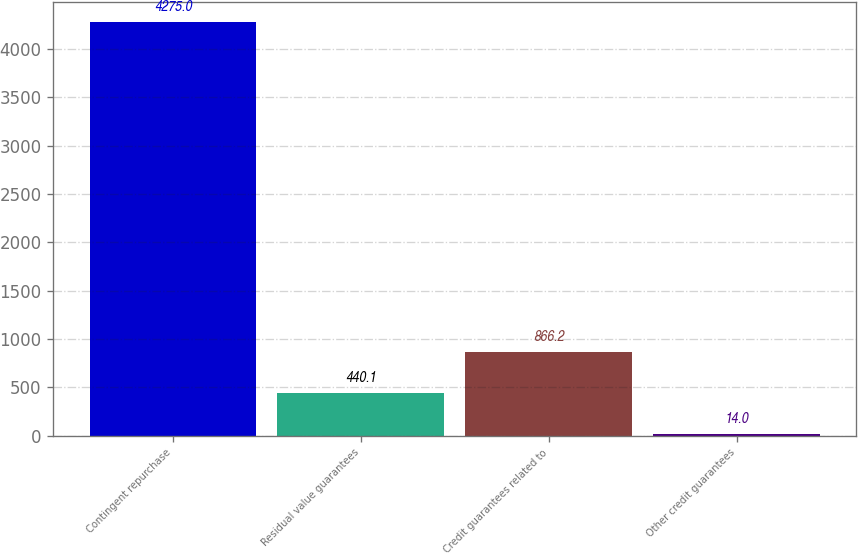Convert chart. <chart><loc_0><loc_0><loc_500><loc_500><bar_chart><fcel>Contingent repurchase<fcel>Residual value guarantees<fcel>Credit guarantees related to<fcel>Other credit guarantees<nl><fcel>4275<fcel>440.1<fcel>866.2<fcel>14<nl></chart> 